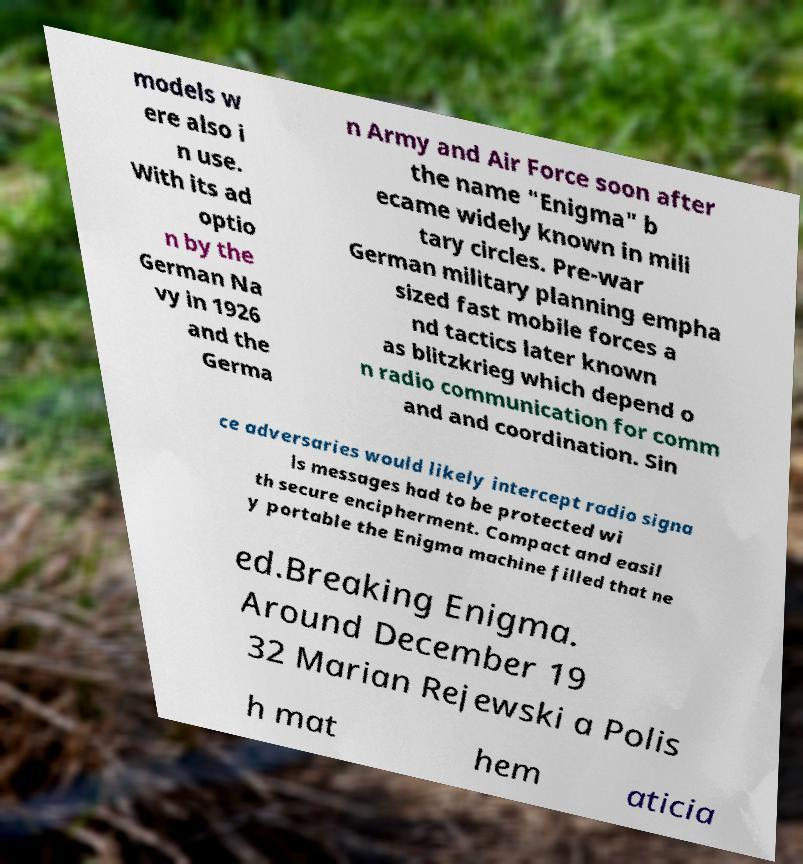Please read and relay the text visible in this image. What does it say? models w ere also i n use. With its ad optio n by the German Na vy in 1926 and the Germa n Army and Air Force soon after the name "Enigma" b ecame widely known in mili tary circles. Pre-war German military planning empha sized fast mobile forces a nd tactics later known as blitzkrieg which depend o n radio communication for comm and and coordination. Sin ce adversaries would likely intercept radio signa ls messages had to be protected wi th secure encipherment. Compact and easil y portable the Enigma machine filled that ne ed.Breaking Enigma. Around December 19 32 Marian Rejewski a Polis h mat hem aticia 